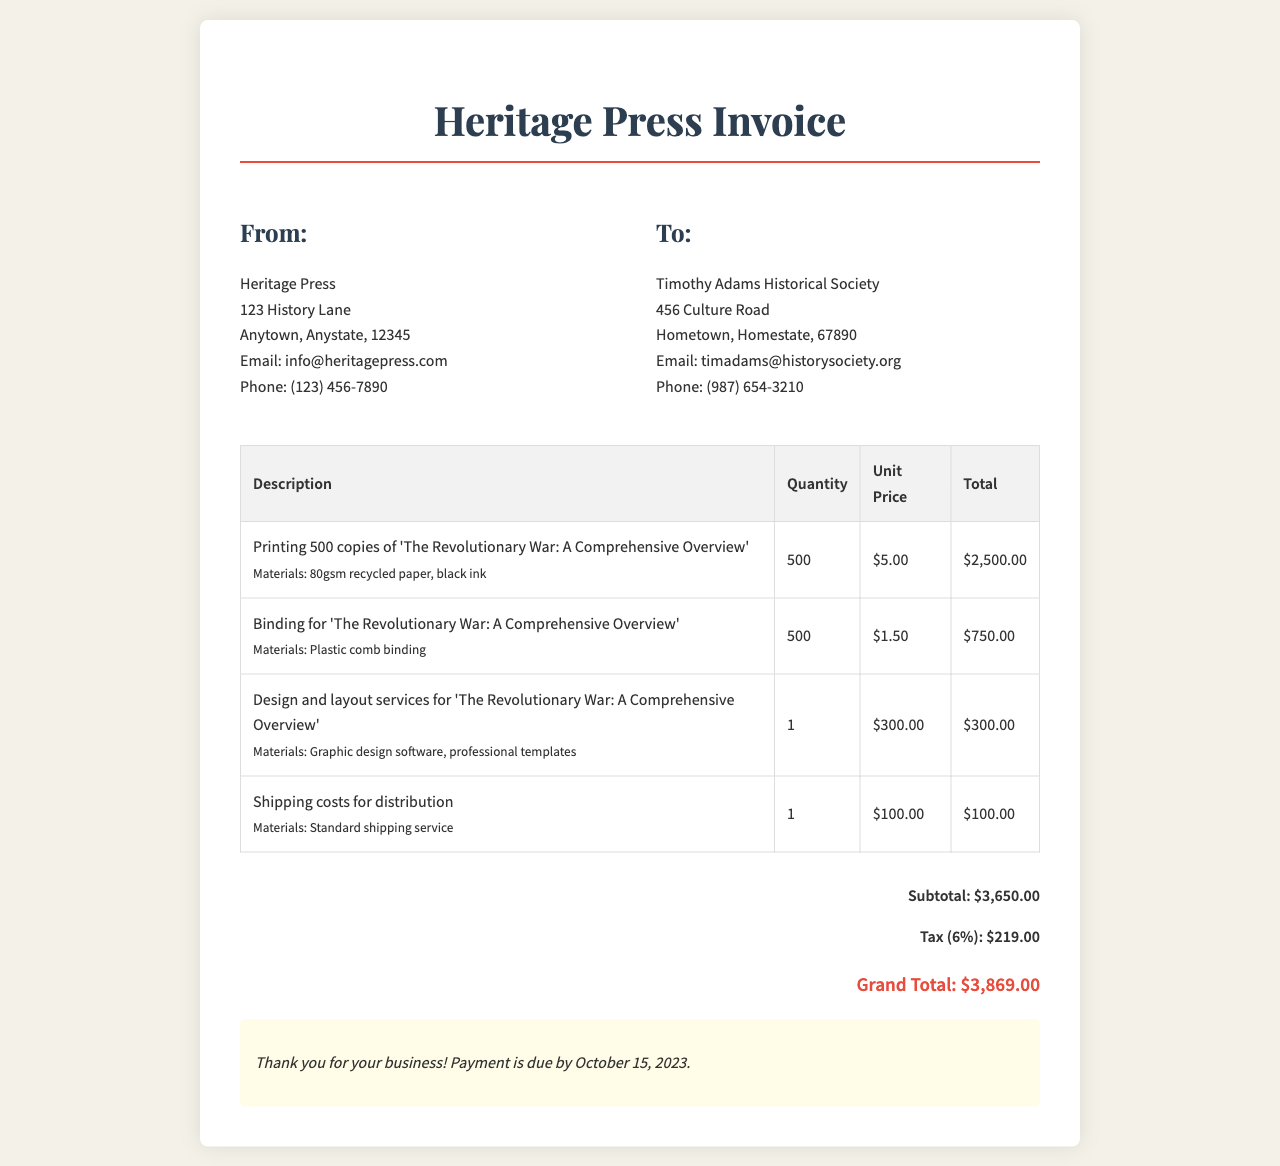What is the invoice date? The document does not explicitly state an invoice date, but payment is due by October 15, 2023.
Answer: October 15, 2023 What is the total cost for printing? The total cost for printing is specified in the table under "Total".
Answer: $2,500.00 What materials were used for binding? The materials used for binding are listed in the description of the binding service.
Answer: Plastic comb binding What is the subtotal amount? The subtotal is clearly mentioned in the total section of the invoice.
Answer: $3,650.00 How much is the tax percentage applied? The tax is calculated at 6%, which is mentioned next to the tax total.
Answer: 6% Which company receives the invoice? The recipient of the invoice is detailed in the client section.
Answer: Timothy Adams Historical Society What type of paper was used for printing? The type of paper used is specified in the printing service description.
Answer: 80gsm recycled paper What is the grand total amount? The grand total is the sum of the subtotal and tax, as detailed at the end of the total section.
Answer: $3,869.00 How many copies of the book were printed? The quantity of copies printed is stated in the printing service row of the invoice.
Answer: 500 